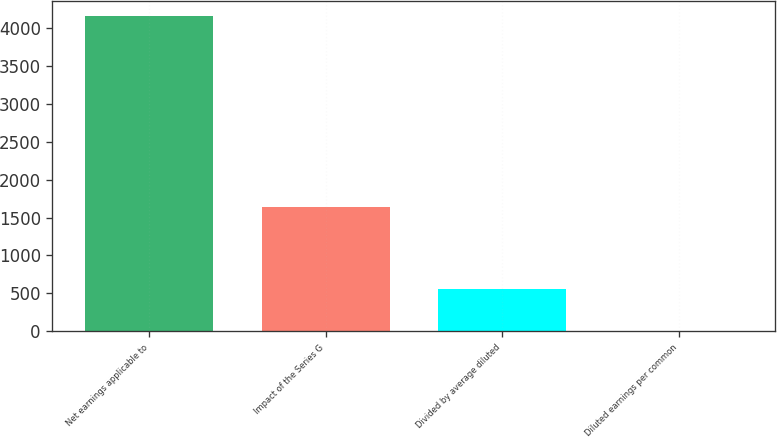Convert chart to OTSL. <chart><loc_0><loc_0><loc_500><loc_500><bar_chart><fcel>Net earnings applicable to<fcel>Impact of the Series G<fcel>Divided by average diluted<fcel>Diluted earnings per common<nl><fcel>4153<fcel>1643<fcel>556.9<fcel>7.46<nl></chart> 